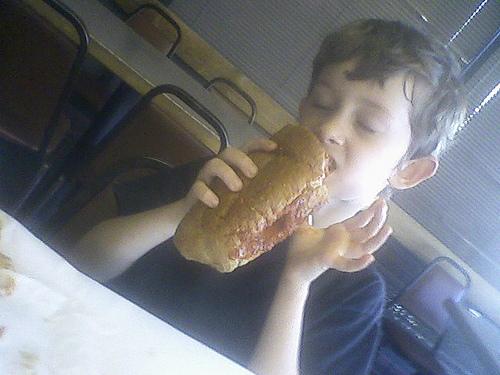What color is the boys shirt?
Short answer required. Blue. Is his eyes closed?
Quick response, please. Yes. What is this boy eating?
Short answer required. Sandwich. 